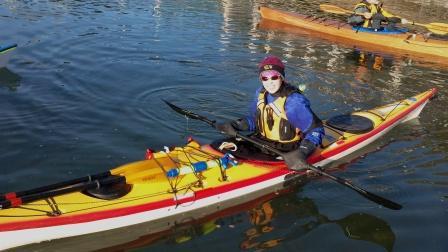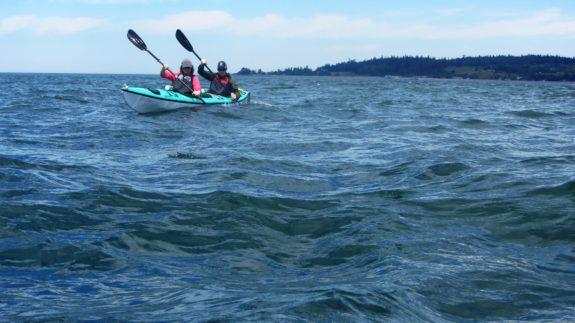The first image is the image on the left, the second image is the image on the right. Evaluate the accuracy of this statement regarding the images: "An image shows a single boat, which has at least four rowers.". Is it true? Answer yes or no. No. 